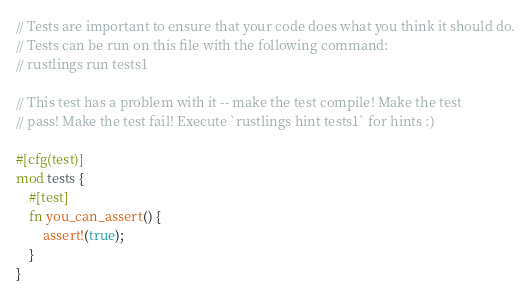Convert code to text. <code><loc_0><loc_0><loc_500><loc_500><_Rust_>// Tests are important to ensure that your code does what you think it should do.
// Tests can be run on this file with the following command:
// rustlings run tests1

// This test has a problem with it -- make the test compile! Make the test
// pass! Make the test fail! Execute `rustlings hint tests1` for hints :)

#[cfg(test)]
mod tests {
    #[test]
    fn you_can_assert() {
        assert!(true);
    }
}</code> 